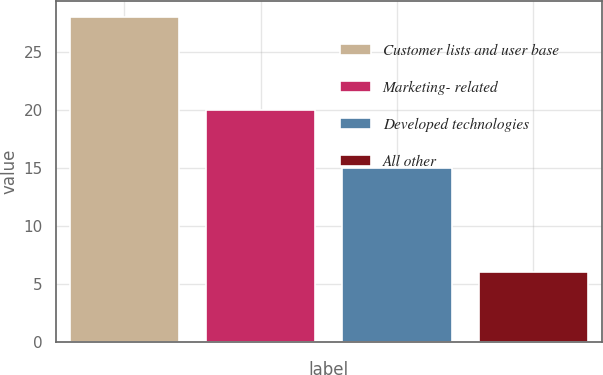Convert chart to OTSL. <chart><loc_0><loc_0><loc_500><loc_500><bar_chart><fcel>Customer lists and user base<fcel>Marketing- related<fcel>Developed technologies<fcel>All other<nl><fcel>28<fcel>20<fcel>15<fcel>6<nl></chart> 